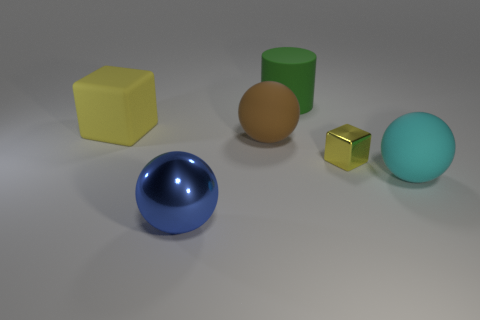What can you infer about the material properties of the objects? Based on the reflections and texture, all objects seem to have a matte finish except for the blue sphere and golden cube, which have a shinier appearance, suggesting a more reflective material like polished metal or plastic.  How does the lighting affect the appearance of the objects? The lighting in the image casts soft shadows and highlights on the objects, accentuating their three-dimensional shapes. The gentle lighting condition does not create harsh contrasts, thereby maintaining a calm and even composition. 